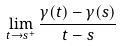Convert formula to latex. <formula><loc_0><loc_0><loc_500><loc_500>\lim _ { t \rightarrow s ^ { + } } \frac { \gamma ( t ) - \gamma ( s ) } { t - s }</formula> 